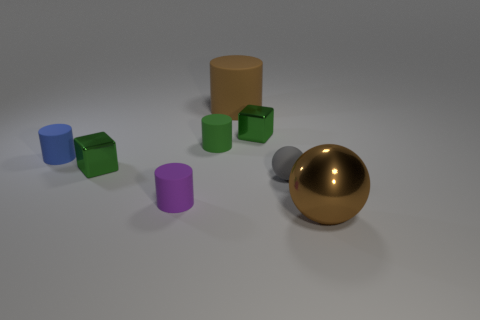Subtract 1 cylinders. How many cylinders are left? 3 Subtract all cyan cylinders. Subtract all purple spheres. How many cylinders are left? 4 Add 1 small gray blocks. How many objects exist? 9 Subtract all spheres. How many objects are left? 6 Add 8 green metal objects. How many green metal objects are left? 10 Add 7 brown things. How many brown things exist? 9 Subtract 0 red cubes. How many objects are left? 8 Subtract all tiny brown cylinders. Subtract all small matte things. How many objects are left? 4 